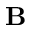Convert formula to latex. <formula><loc_0><loc_0><loc_500><loc_500>B</formula> 